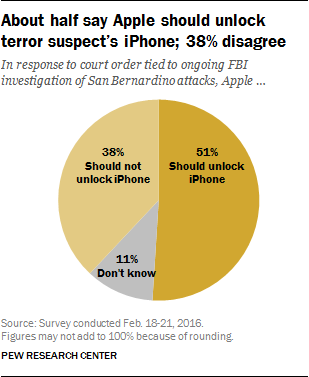What implications could this survey have on public policy? Surveys like this one can influence public policy by providing a snapshot of public opinion at a particular time. Policymakers might use this data to gauge the support for legislation that balances national security interests with individual privacy rights. The mixed results suggest a need for a careful approach that considers the diverse opinions of the populace. 